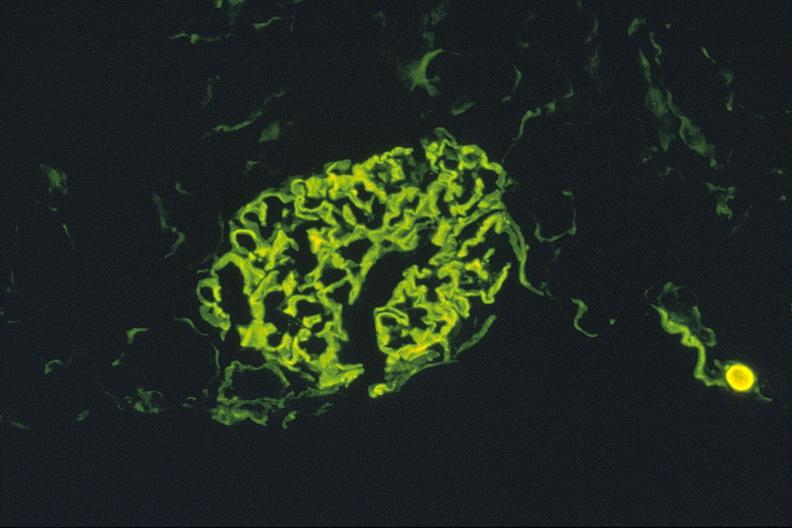where is this?
Answer the question using a single word or phrase. Urinary 